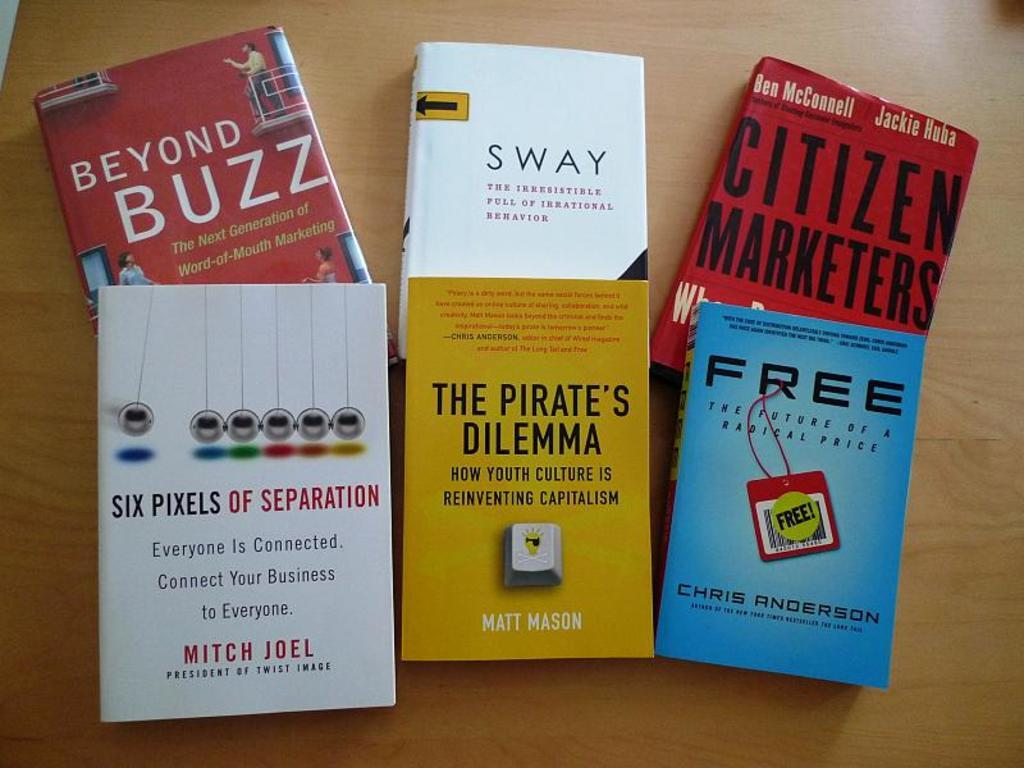<image>
Give a short and clear explanation of the subsequent image. The Pirate's Dilemma is on a table with five other books. 